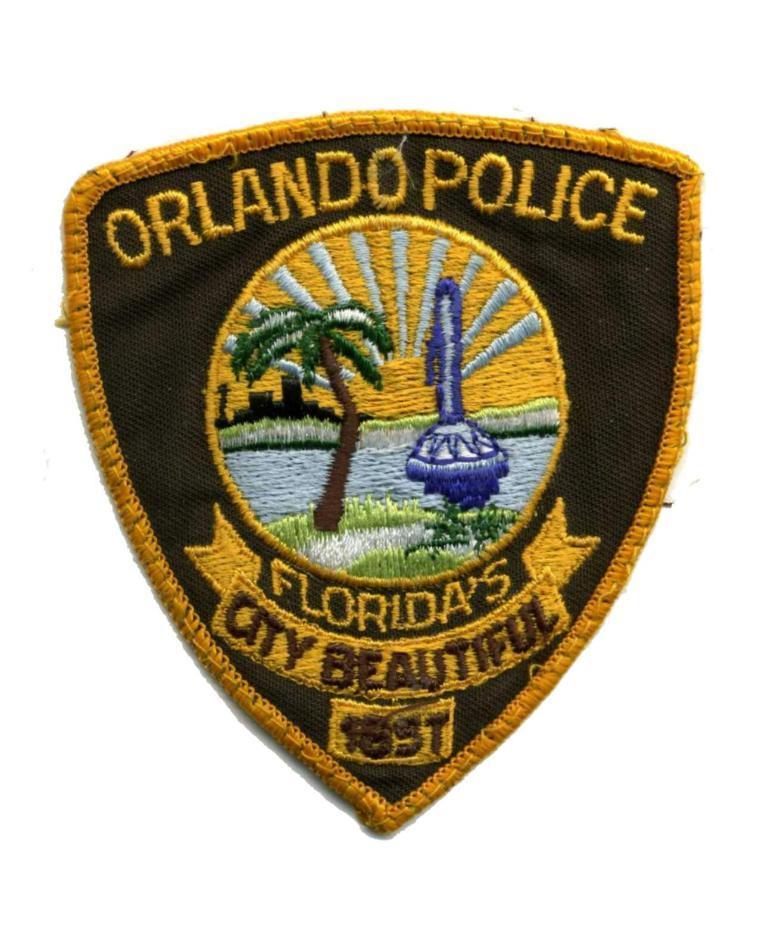Could you give a brief overview of what you see in this image? In this image we can see a logo with some text and pictures. 